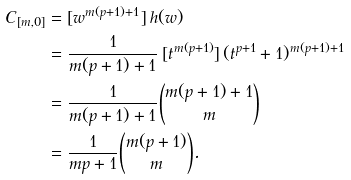Convert formula to latex. <formula><loc_0><loc_0><loc_500><loc_500>C _ { [ m , 0 ] } & = [ w ^ { m ( p + 1 ) + 1 } ] \, h ( w ) \\ & = \frac { 1 } { m ( p + 1 ) + 1 } \, [ t ^ { m ( p + 1 ) } ] \, ( t ^ { p + 1 } + 1 ) ^ { m ( p + 1 ) + 1 } \\ & = \frac { 1 } { m ( p + 1 ) + 1 } \binom { m ( p + 1 ) + 1 } { m } \\ & = \frac { 1 } { m p + 1 } \binom { m ( p + 1 ) } { m } .</formula> 